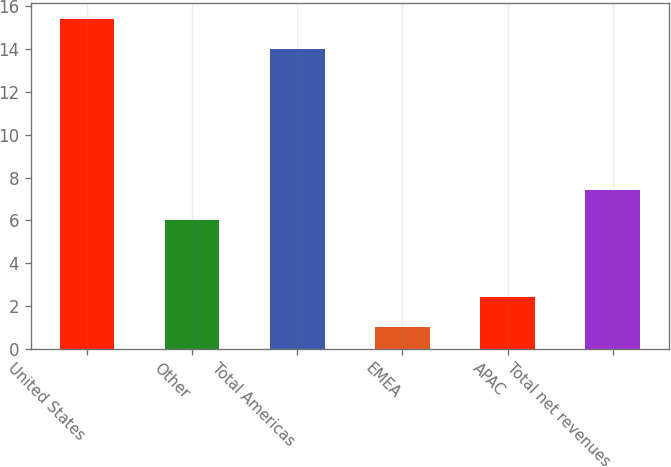Convert chart to OTSL. <chart><loc_0><loc_0><loc_500><loc_500><bar_chart><fcel>United States<fcel>Other<fcel>Total Americas<fcel>EMEA<fcel>APAC<fcel>Total net revenues<nl><fcel>15.4<fcel>6<fcel>14<fcel>1<fcel>2.4<fcel>7.4<nl></chart> 